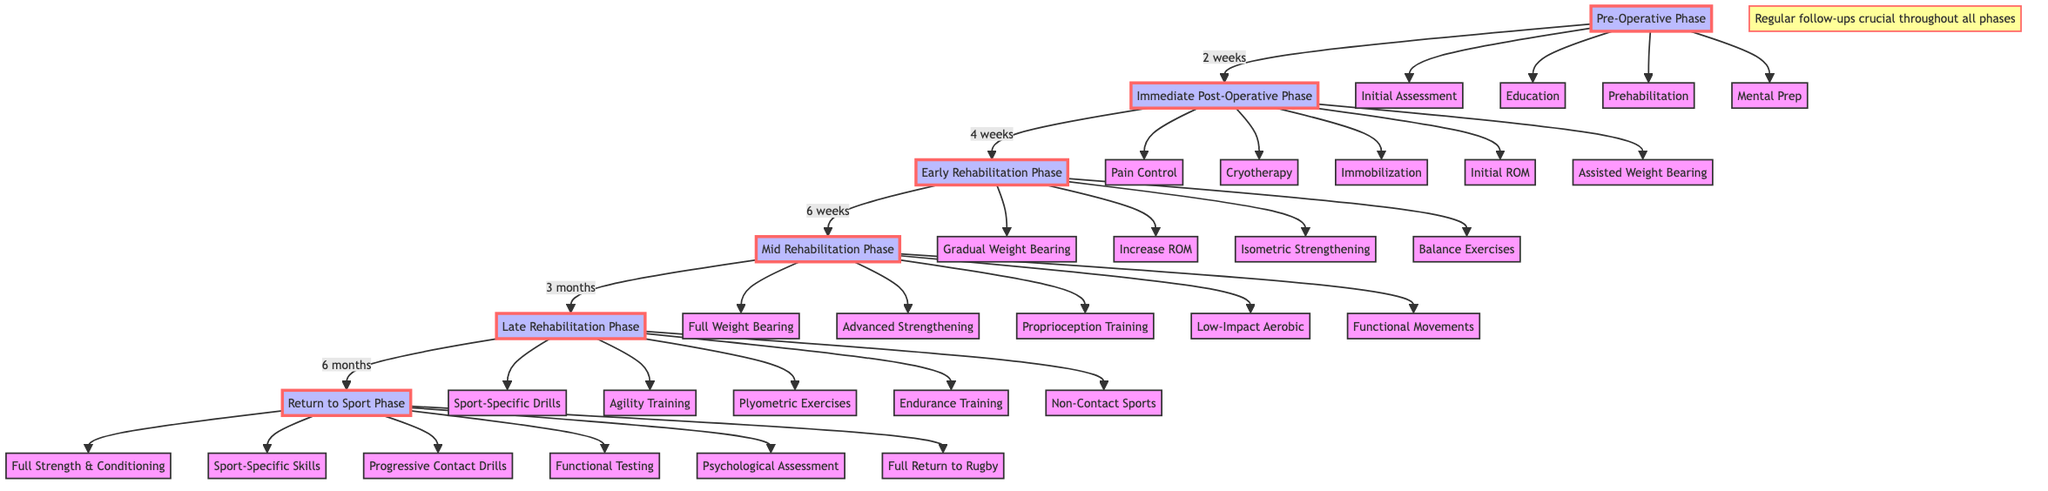What is the first phase in the pathway? The diagram starts with the Pre-Operative Phase, which is the first node in the pathway.
Answer: Pre-Operative Phase How many elements are in the Mid Rehabilitation Phase? The Mid Rehabilitation Phase has five elements listed, including Full Weight Bearing and Advanced Strengthening Exercises.
Answer: 5 What follows the Early Rehabilitation Phase? The diagram indicates that the Early Rehabilitation Phase transitions to the Mid Rehabilitation Phase, which is the next step in the pathway.
Answer: Mid Rehabilitation Phase What type of exercises begin in the Late Rehabilitation Phase? The Late Rehabilitation Phase includes Sport-Specific Drills as one of its initial activities.
Answer: Sport-Specific Drills What preparation activities are included in the Pre-Operative Phase? The Pre-Operative Phase contains elements such as Initial Assessment, Education on Surgery and Rehab, Prehabilitation Exercises, and Mental Preparation.
Answer: Initial Assessment, Education, Prehabilitation, Mental Preparation What is the duration of the Immediate Post-Operative Phase? The Immediate Post-Operative Phase lasts for two weeks, as indicated in the timeline leading to the next phase.
Answer: 2 weeks What note is provided regarding follow-ups? There is a note in the diagram emphasizing the importance of regular follow-ups with the orthopedic surgeon and physiotherapist throughout all phases.
Answer: Regular follow-ups crucial throughout all phases What type of training begins in the Return to Sport Phase? The Return to Sport Phase initiates with Full Strength and Conditioning activities as the first element.
Answer: Full Strength and Conditioning Which phase involves psychological readiness assessment? The Psychological Readiness Assessment is a key element in the Return to Sport Phase, highlighting the importance of mental preparedness for the athlete's return.
Answer: Return to Sport Phase 